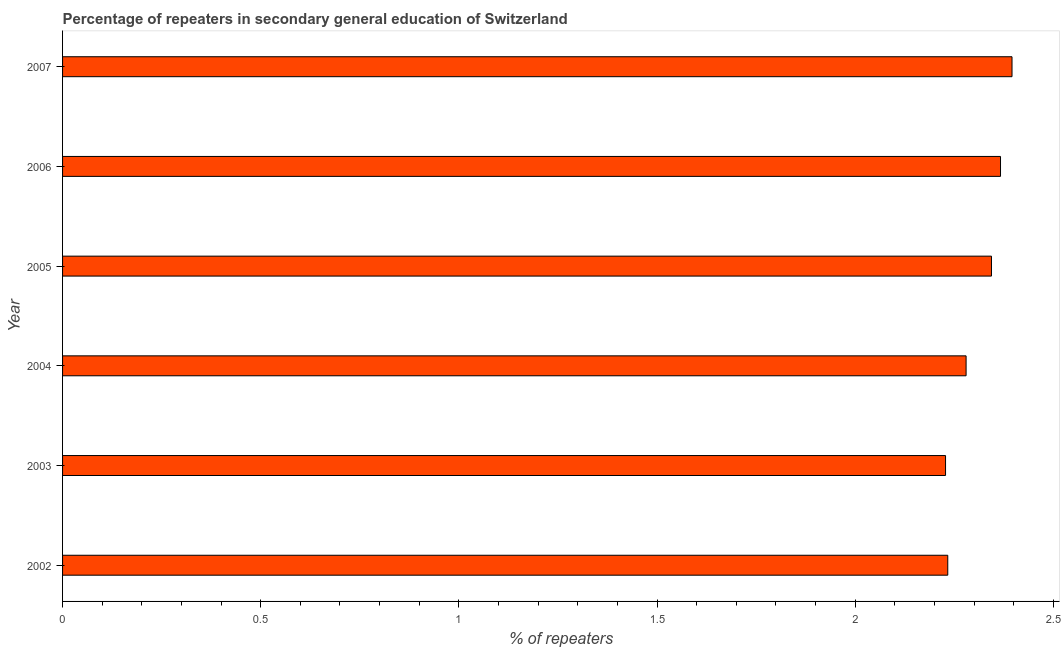Does the graph contain any zero values?
Offer a terse response. No. Does the graph contain grids?
Offer a very short reply. No. What is the title of the graph?
Offer a very short reply. Percentage of repeaters in secondary general education of Switzerland. What is the label or title of the X-axis?
Offer a very short reply. % of repeaters. What is the label or title of the Y-axis?
Provide a succinct answer. Year. What is the percentage of repeaters in 2005?
Provide a short and direct response. 2.34. Across all years, what is the maximum percentage of repeaters?
Keep it short and to the point. 2.4. Across all years, what is the minimum percentage of repeaters?
Keep it short and to the point. 2.23. In which year was the percentage of repeaters maximum?
Offer a terse response. 2007. What is the sum of the percentage of repeaters?
Make the answer very short. 13.85. What is the difference between the percentage of repeaters in 2005 and 2007?
Ensure brevity in your answer.  -0.05. What is the average percentage of repeaters per year?
Ensure brevity in your answer.  2.31. What is the median percentage of repeaters?
Offer a terse response. 2.31. Do a majority of the years between 2004 and 2005 (inclusive) have percentage of repeaters greater than 1.8 %?
Make the answer very short. Yes. What is the ratio of the percentage of repeaters in 2003 to that in 2005?
Offer a very short reply. 0.95. What is the difference between the highest and the second highest percentage of repeaters?
Your response must be concise. 0.03. Is the sum of the percentage of repeaters in 2005 and 2006 greater than the maximum percentage of repeaters across all years?
Provide a succinct answer. Yes. What is the difference between the highest and the lowest percentage of repeaters?
Your answer should be very brief. 0.17. Are all the bars in the graph horizontal?
Provide a succinct answer. Yes. What is the % of repeaters in 2002?
Provide a succinct answer. 2.23. What is the % of repeaters of 2003?
Your response must be concise. 2.23. What is the % of repeaters in 2004?
Provide a succinct answer. 2.28. What is the % of repeaters of 2005?
Keep it short and to the point. 2.34. What is the % of repeaters in 2006?
Your response must be concise. 2.37. What is the % of repeaters in 2007?
Give a very brief answer. 2.4. What is the difference between the % of repeaters in 2002 and 2003?
Offer a very short reply. 0.01. What is the difference between the % of repeaters in 2002 and 2004?
Offer a very short reply. -0.05. What is the difference between the % of repeaters in 2002 and 2005?
Make the answer very short. -0.11. What is the difference between the % of repeaters in 2002 and 2006?
Give a very brief answer. -0.13. What is the difference between the % of repeaters in 2002 and 2007?
Ensure brevity in your answer.  -0.16. What is the difference between the % of repeaters in 2003 and 2004?
Your answer should be very brief. -0.05. What is the difference between the % of repeaters in 2003 and 2005?
Your response must be concise. -0.12. What is the difference between the % of repeaters in 2003 and 2006?
Provide a short and direct response. -0.14. What is the difference between the % of repeaters in 2003 and 2007?
Offer a terse response. -0.17. What is the difference between the % of repeaters in 2004 and 2005?
Give a very brief answer. -0.06. What is the difference between the % of repeaters in 2004 and 2006?
Give a very brief answer. -0.09. What is the difference between the % of repeaters in 2004 and 2007?
Provide a succinct answer. -0.12. What is the difference between the % of repeaters in 2005 and 2006?
Offer a very short reply. -0.02. What is the difference between the % of repeaters in 2005 and 2007?
Give a very brief answer. -0.05. What is the difference between the % of repeaters in 2006 and 2007?
Ensure brevity in your answer.  -0.03. What is the ratio of the % of repeaters in 2002 to that in 2005?
Make the answer very short. 0.95. What is the ratio of the % of repeaters in 2002 to that in 2006?
Keep it short and to the point. 0.94. What is the ratio of the % of repeaters in 2002 to that in 2007?
Offer a terse response. 0.93. What is the ratio of the % of repeaters in 2003 to that in 2005?
Make the answer very short. 0.95. What is the ratio of the % of repeaters in 2003 to that in 2006?
Offer a very short reply. 0.94. What is the ratio of the % of repeaters in 2004 to that in 2005?
Ensure brevity in your answer.  0.97. What is the ratio of the % of repeaters in 2004 to that in 2007?
Your answer should be compact. 0.95. What is the ratio of the % of repeaters in 2005 to that in 2006?
Give a very brief answer. 0.99. What is the ratio of the % of repeaters in 2005 to that in 2007?
Make the answer very short. 0.98. 